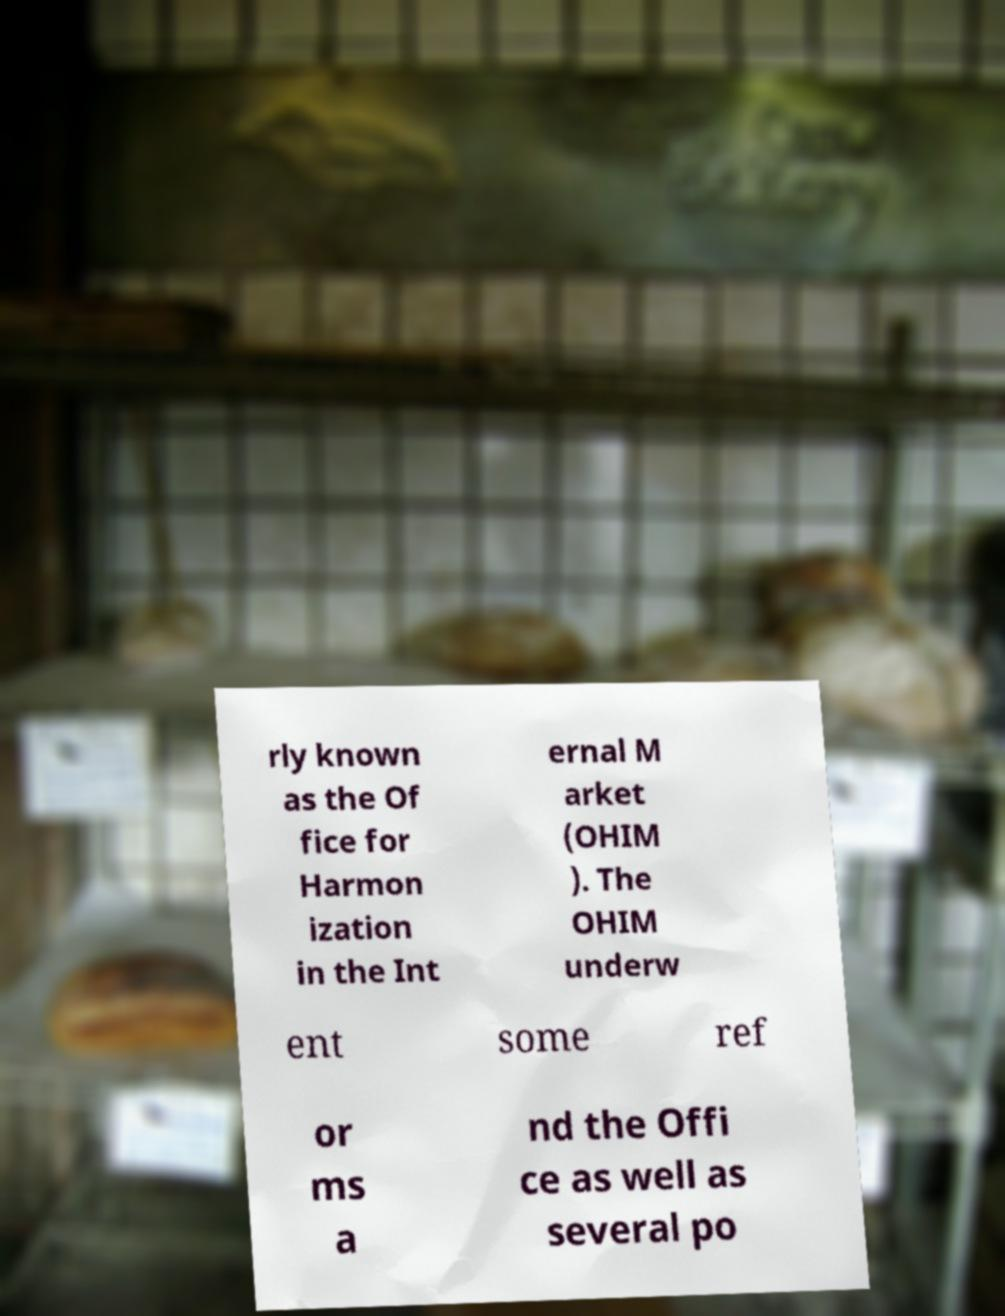Please read and relay the text visible in this image. What does it say? rly known as the Of fice for Harmon ization in the Int ernal M arket (OHIM ). The OHIM underw ent some ref or ms a nd the Offi ce as well as several po 